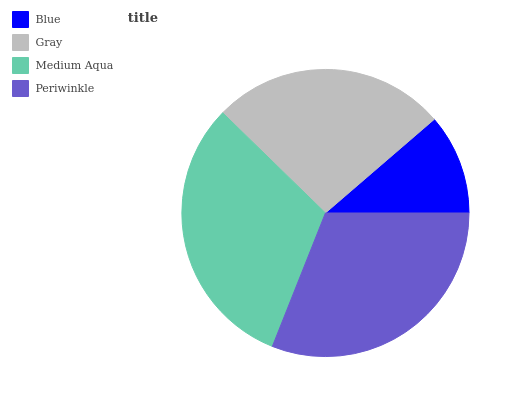Is Blue the minimum?
Answer yes or no. Yes. Is Medium Aqua the maximum?
Answer yes or no. Yes. Is Gray the minimum?
Answer yes or no. No. Is Gray the maximum?
Answer yes or no. No. Is Gray greater than Blue?
Answer yes or no. Yes. Is Blue less than Gray?
Answer yes or no. Yes. Is Blue greater than Gray?
Answer yes or no. No. Is Gray less than Blue?
Answer yes or no. No. Is Periwinkle the high median?
Answer yes or no. Yes. Is Gray the low median?
Answer yes or no. Yes. Is Blue the high median?
Answer yes or no. No. Is Blue the low median?
Answer yes or no. No. 